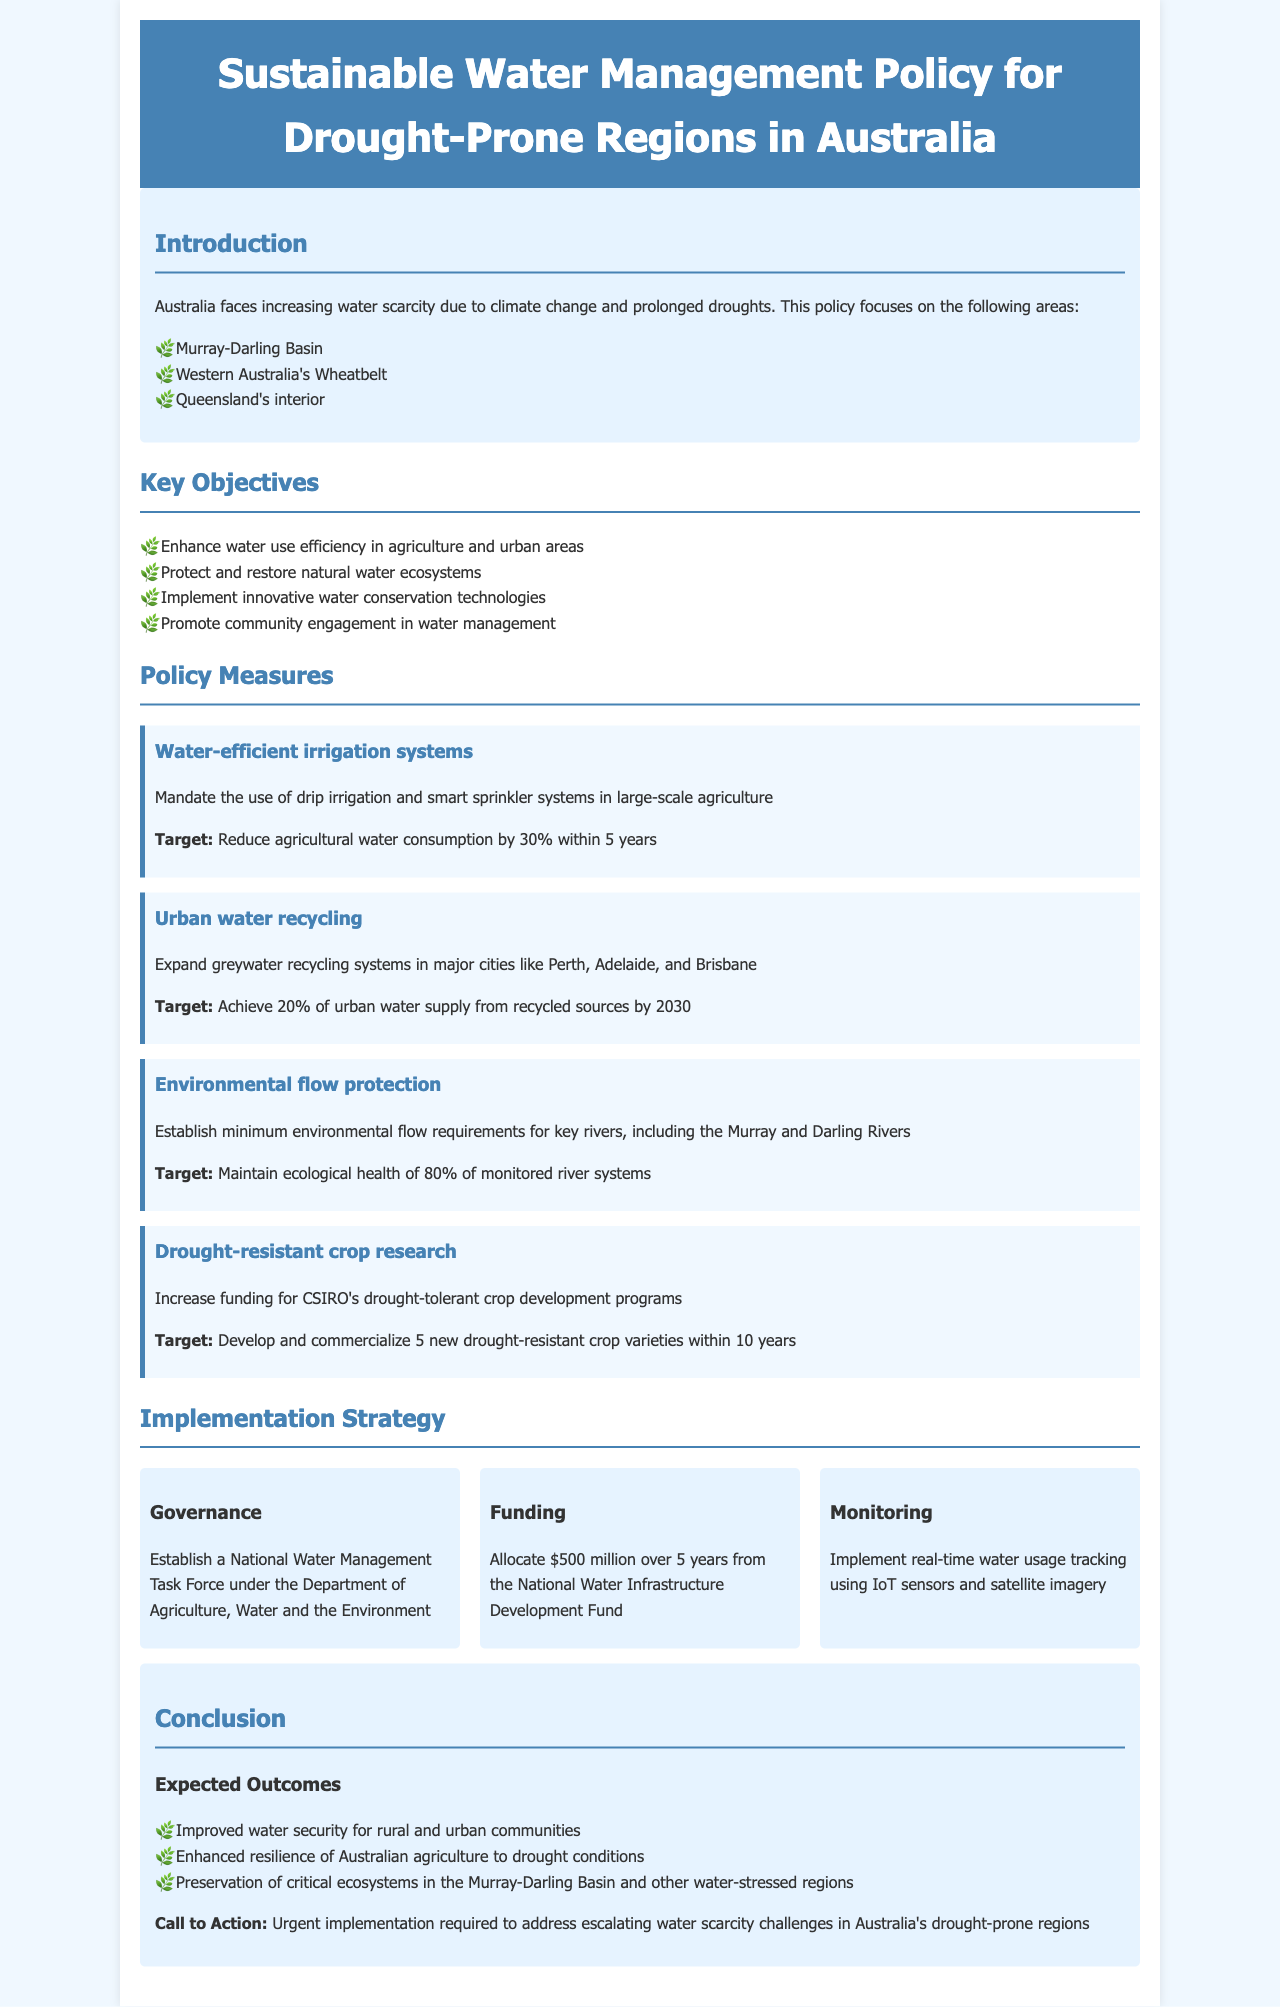What are the key areas of focus? The document highlights the specific regions of focus for the policy: the Murray-Darling Basin, Western Australia's Wheatbelt, and Queensland's interior.
Answer: Murray-Darling Basin, Western Australia's Wheatbelt, Queensland's interior What is the target reduction for agricultural water consumption? The policy measures specify a target to reduce agricultural water consumption by 30% within 5 years through the implementation of water-efficient irrigation systems.
Answer: 30% Which cities are mentioned for expanding greywater recycling systems? The policy mentions expanding greywater recycling systems in major cities like Perth, Adelaide, and Brisbane.
Answer: Perth, Adelaide, Brisbane What is the funding allocation for the policy? The document states that $500 million will be allocated over 5 years from the National Water Infrastructure Development Fund to support the implementation of the policy measures.
Answer: $500 million What is the expected ecological health target for monitored river systems? The policy sets a target to maintain the ecological health of 80% of monitored river systems through environmental flow protection measures.
Answer: 80% Which government entity will establish a task force for water management? The policy specifies that a National Water Management Task Force will be established under the Department of Agriculture, Water and the Environment.
Answer: Department of Agriculture, Water and the Environment What is the target for urban water supply from recycled sources by 2030? The document outlines a target to achieve 20% of urban water supply from recycled sources by 2030 through urban water recycling initiatives.
Answer: 20% How many drought-resistant crop varieties are aimed to be developed? The policy aims to develop and commercialize 5 new drought-resistant crop varieties within 10 years as part of its drought-resistant crop research measures.
Answer: 5 